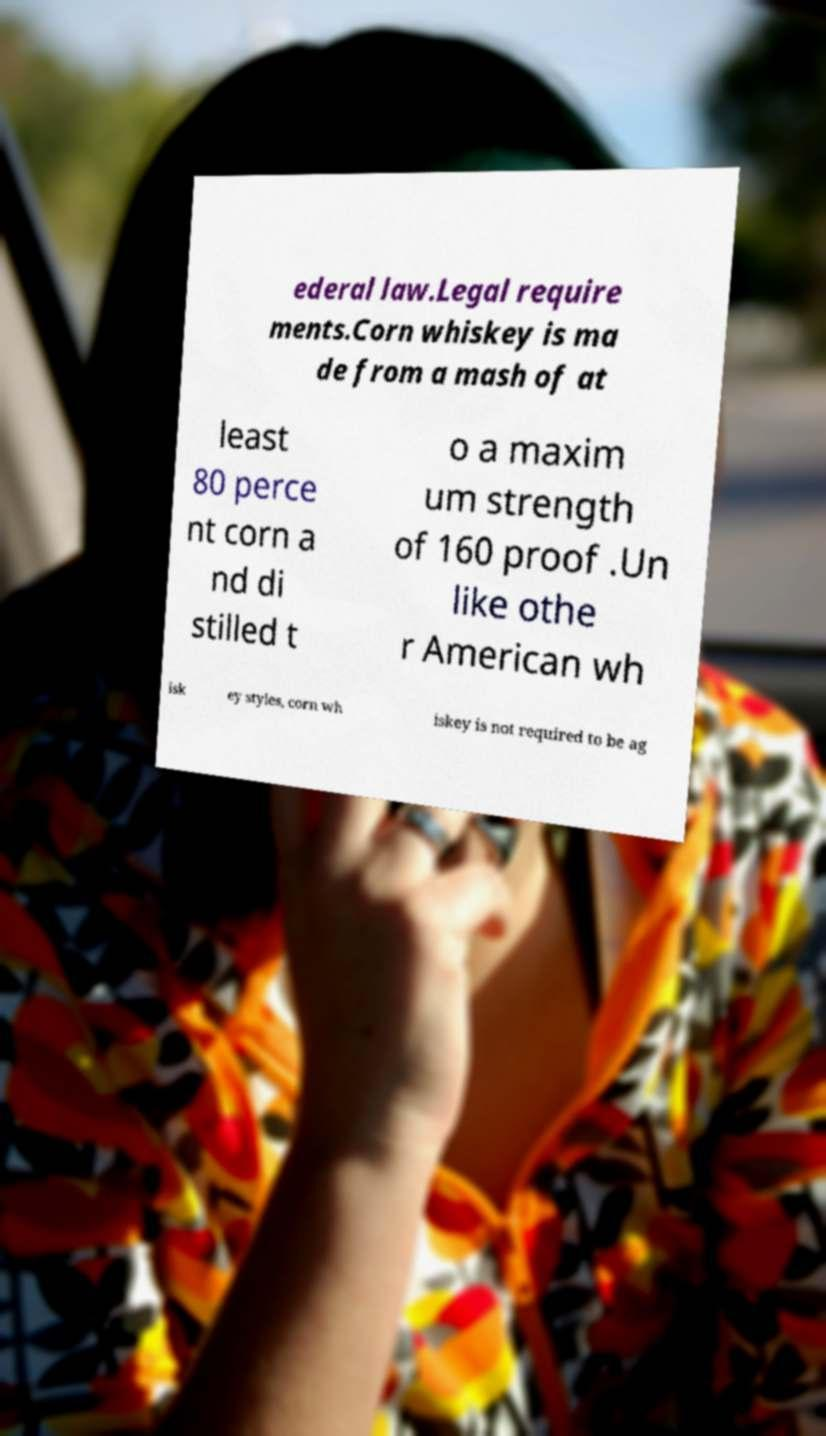Could you extract and type out the text from this image? ederal law.Legal require ments.Corn whiskey is ma de from a mash of at least 80 perce nt corn a nd di stilled t o a maxim um strength of 160 proof .Un like othe r American wh isk ey styles, corn wh iskey is not required to be ag 